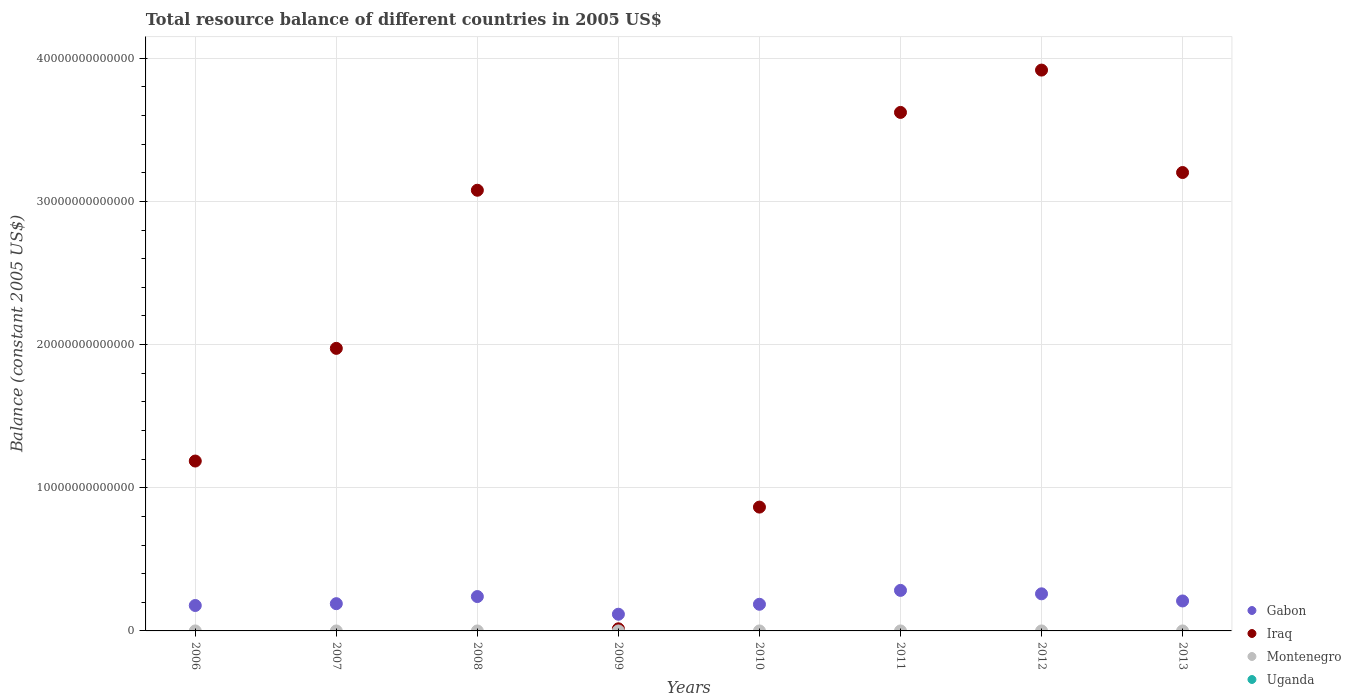How many different coloured dotlines are there?
Provide a short and direct response. 2. Is the number of dotlines equal to the number of legend labels?
Your response must be concise. No. What is the total resource balance in Iraq in 2010?
Make the answer very short. 8.65e+12. Across all years, what is the maximum total resource balance in Gabon?
Provide a short and direct response. 2.83e+12. Across all years, what is the minimum total resource balance in Gabon?
Your answer should be very brief. 1.17e+12. What is the total total resource balance in Iraq in the graph?
Provide a succinct answer. 1.79e+14. What is the difference between the total resource balance in Iraq in 2006 and that in 2010?
Keep it short and to the point. 3.22e+12. What is the difference between the total resource balance in Uganda in 2009 and the total resource balance in Montenegro in 2008?
Keep it short and to the point. 0. What is the average total resource balance in Iraq per year?
Your response must be concise. 2.23e+13. In the year 2012, what is the difference between the total resource balance in Iraq and total resource balance in Gabon?
Your answer should be compact. 3.66e+13. In how many years, is the total resource balance in Montenegro greater than 10000000000000 US$?
Your answer should be very brief. 0. What is the ratio of the total resource balance in Gabon in 2007 to that in 2009?
Make the answer very short. 1.63. Is the difference between the total resource balance in Iraq in 2007 and 2012 greater than the difference between the total resource balance in Gabon in 2007 and 2012?
Give a very brief answer. No. What is the difference between the highest and the second highest total resource balance in Iraq?
Provide a short and direct response. 2.96e+12. What is the difference between the highest and the lowest total resource balance in Iraq?
Make the answer very short. 3.90e+13. In how many years, is the total resource balance in Iraq greater than the average total resource balance in Iraq taken over all years?
Ensure brevity in your answer.  4. Is the sum of the total resource balance in Iraq in 2006 and 2010 greater than the maximum total resource balance in Uganda across all years?
Give a very brief answer. Yes. Is it the case that in every year, the sum of the total resource balance in Montenegro and total resource balance in Gabon  is greater than the total resource balance in Iraq?
Provide a succinct answer. No. Does the total resource balance in Montenegro monotonically increase over the years?
Offer a very short reply. No. Is the total resource balance in Uganda strictly greater than the total resource balance in Iraq over the years?
Give a very brief answer. No. Is the total resource balance in Montenegro strictly less than the total resource balance in Gabon over the years?
Provide a succinct answer. Yes. How many years are there in the graph?
Your answer should be compact. 8. What is the difference between two consecutive major ticks on the Y-axis?
Offer a terse response. 1.00e+13. Are the values on the major ticks of Y-axis written in scientific E-notation?
Give a very brief answer. No. Does the graph contain any zero values?
Your answer should be compact. Yes. How many legend labels are there?
Provide a short and direct response. 4. How are the legend labels stacked?
Ensure brevity in your answer.  Vertical. What is the title of the graph?
Your answer should be compact. Total resource balance of different countries in 2005 US$. Does "Brunei Darussalam" appear as one of the legend labels in the graph?
Give a very brief answer. No. What is the label or title of the X-axis?
Offer a terse response. Years. What is the label or title of the Y-axis?
Provide a succinct answer. Balance (constant 2005 US$). What is the Balance (constant 2005 US$) in Gabon in 2006?
Your response must be concise. 1.78e+12. What is the Balance (constant 2005 US$) in Iraq in 2006?
Ensure brevity in your answer.  1.19e+13. What is the Balance (constant 2005 US$) of Gabon in 2007?
Provide a short and direct response. 1.90e+12. What is the Balance (constant 2005 US$) in Iraq in 2007?
Keep it short and to the point. 1.97e+13. What is the Balance (constant 2005 US$) of Gabon in 2008?
Offer a very short reply. 2.40e+12. What is the Balance (constant 2005 US$) in Iraq in 2008?
Make the answer very short. 3.08e+13. What is the Balance (constant 2005 US$) in Uganda in 2008?
Your answer should be very brief. 0. What is the Balance (constant 2005 US$) of Gabon in 2009?
Offer a terse response. 1.17e+12. What is the Balance (constant 2005 US$) of Iraq in 2009?
Offer a terse response. 1.47e+11. What is the Balance (constant 2005 US$) of Gabon in 2010?
Your answer should be compact. 1.86e+12. What is the Balance (constant 2005 US$) in Iraq in 2010?
Ensure brevity in your answer.  8.65e+12. What is the Balance (constant 2005 US$) of Montenegro in 2010?
Provide a succinct answer. 0. What is the Balance (constant 2005 US$) of Uganda in 2010?
Your answer should be compact. 0. What is the Balance (constant 2005 US$) in Gabon in 2011?
Keep it short and to the point. 2.83e+12. What is the Balance (constant 2005 US$) of Iraq in 2011?
Your answer should be very brief. 3.62e+13. What is the Balance (constant 2005 US$) of Montenegro in 2011?
Provide a succinct answer. 0. What is the Balance (constant 2005 US$) of Uganda in 2011?
Make the answer very short. 0. What is the Balance (constant 2005 US$) in Gabon in 2012?
Provide a short and direct response. 2.59e+12. What is the Balance (constant 2005 US$) in Iraq in 2012?
Ensure brevity in your answer.  3.92e+13. What is the Balance (constant 2005 US$) in Montenegro in 2012?
Offer a very short reply. 0. What is the Balance (constant 2005 US$) in Gabon in 2013?
Provide a short and direct response. 2.09e+12. What is the Balance (constant 2005 US$) of Iraq in 2013?
Provide a succinct answer. 3.20e+13. What is the Balance (constant 2005 US$) of Montenegro in 2013?
Your response must be concise. 0. Across all years, what is the maximum Balance (constant 2005 US$) in Gabon?
Your answer should be very brief. 2.83e+12. Across all years, what is the maximum Balance (constant 2005 US$) of Iraq?
Give a very brief answer. 3.92e+13. Across all years, what is the minimum Balance (constant 2005 US$) of Gabon?
Provide a succinct answer. 1.17e+12. Across all years, what is the minimum Balance (constant 2005 US$) in Iraq?
Your response must be concise. 1.47e+11. What is the total Balance (constant 2005 US$) in Gabon in the graph?
Your answer should be compact. 1.66e+13. What is the total Balance (constant 2005 US$) of Iraq in the graph?
Your answer should be compact. 1.79e+14. What is the total Balance (constant 2005 US$) in Montenegro in the graph?
Your answer should be compact. 0. What is the difference between the Balance (constant 2005 US$) in Gabon in 2006 and that in 2007?
Offer a terse response. -1.28e+11. What is the difference between the Balance (constant 2005 US$) in Iraq in 2006 and that in 2007?
Give a very brief answer. -7.87e+12. What is the difference between the Balance (constant 2005 US$) in Gabon in 2006 and that in 2008?
Provide a short and direct response. -6.25e+11. What is the difference between the Balance (constant 2005 US$) of Iraq in 2006 and that in 2008?
Keep it short and to the point. -1.89e+13. What is the difference between the Balance (constant 2005 US$) of Gabon in 2006 and that in 2009?
Give a very brief answer. 6.09e+11. What is the difference between the Balance (constant 2005 US$) in Iraq in 2006 and that in 2009?
Provide a succinct answer. 1.17e+13. What is the difference between the Balance (constant 2005 US$) in Gabon in 2006 and that in 2010?
Give a very brief answer. -8.58e+1. What is the difference between the Balance (constant 2005 US$) of Iraq in 2006 and that in 2010?
Give a very brief answer. 3.22e+12. What is the difference between the Balance (constant 2005 US$) of Gabon in 2006 and that in 2011?
Give a very brief answer. -1.06e+12. What is the difference between the Balance (constant 2005 US$) of Iraq in 2006 and that in 2011?
Offer a very short reply. -2.43e+13. What is the difference between the Balance (constant 2005 US$) in Gabon in 2006 and that in 2012?
Provide a succinct answer. -8.16e+11. What is the difference between the Balance (constant 2005 US$) in Iraq in 2006 and that in 2012?
Provide a succinct answer. -2.73e+13. What is the difference between the Balance (constant 2005 US$) in Gabon in 2006 and that in 2013?
Your answer should be very brief. -3.17e+11. What is the difference between the Balance (constant 2005 US$) in Iraq in 2006 and that in 2013?
Give a very brief answer. -2.02e+13. What is the difference between the Balance (constant 2005 US$) in Gabon in 2007 and that in 2008?
Ensure brevity in your answer.  -4.98e+11. What is the difference between the Balance (constant 2005 US$) in Iraq in 2007 and that in 2008?
Ensure brevity in your answer.  -1.10e+13. What is the difference between the Balance (constant 2005 US$) of Gabon in 2007 and that in 2009?
Make the answer very short. 7.37e+11. What is the difference between the Balance (constant 2005 US$) in Iraq in 2007 and that in 2009?
Your answer should be very brief. 1.96e+13. What is the difference between the Balance (constant 2005 US$) of Gabon in 2007 and that in 2010?
Ensure brevity in your answer.  4.21e+1. What is the difference between the Balance (constant 2005 US$) in Iraq in 2007 and that in 2010?
Offer a very short reply. 1.11e+13. What is the difference between the Balance (constant 2005 US$) of Gabon in 2007 and that in 2011?
Ensure brevity in your answer.  -9.28e+11. What is the difference between the Balance (constant 2005 US$) in Iraq in 2007 and that in 2011?
Provide a succinct answer. -1.65e+13. What is the difference between the Balance (constant 2005 US$) in Gabon in 2007 and that in 2012?
Keep it short and to the point. -6.88e+11. What is the difference between the Balance (constant 2005 US$) in Iraq in 2007 and that in 2012?
Provide a succinct answer. -1.94e+13. What is the difference between the Balance (constant 2005 US$) in Gabon in 2007 and that in 2013?
Offer a very short reply. -1.90e+11. What is the difference between the Balance (constant 2005 US$) in Iraq in 2007 and that in 2013?
Your answer should be compact. -1.23e+13. What is the difference between the Balance (constant 2005 US$) of Gabon in 2008 and that in 2009?
Your response must be concise. 1.23e+12. What is the difference between the Balance (constant 2005 US$) of Iraq in 2008 and that in 2009?
Your response must be concise. 3.06e+13. What is the difference between the Balance (constant 2005 US$) in Gabon in 2008 and that in 2010?
Offer a terse response. 5.40e+11. What is the difference between the Balance (constant 2005 US$) of Iraq in 2008 and that in 2010?
Your answer should be compact. 2.21e+13. What is the difference between the Balance (constant 2005 US$) of Gabon in 2008 and that in 2011?
Give a very brief answer. -4.30e+11. What is the difference between the Balance (constant 2005 US$) of Iraq in 2008 and that in 2011?
Provide a succinct answer. -5.44e+12. What is the difference between the Balance (constant 2005 US$) in Gabon in 2008 and that in 2012?
Your answer should be compact. -1.91e+11. What is the difference between the Balance (constant 2005 US$) of Iraq in 2008 and that in 2012?
Your answer should be compact. -8.39e+12. What is the difference between the Balance (constant 2005 US$) in Gabon in 2008 and that in 2013?
Make the answer very short. 3.08e+11. What is the difference between the Balance (constant 2005 US$) in Iraq in 2008 and that in 2013?
Your answer should be compact. -1.24e+12. What is the difference between the Balance (constant 2005 US$) of Gabon in 2009 and that in 2010?
Keep it short and to the point. -6.95e+11. What is the difference between the Balance (constant 2005 US$) in Iraq in 2009 and that in 2010?
Make the answer very short. -8.50e+12. What is the difference between the Balance (constant 2005 US$) in Gabon in 2009 and that in 2011?
Make the answer very short. -1.66e+12. What is the difference between the Balance (constant 2005 US$) in Iraq in 2009 and that in 2011?
Offer a terse response. -3.61e+13. What is the difference between the Balance (constant 2005 US$) in Gabon in 2009 and that in 2012?
Provide a succinct answer. -1.42e+12. What is the difference between the Balance (constant 2005 US$) of Iraq in 2009 and that in 2012?
Offer a terse response. -3.90e+13. What is the difference between the Balance (constant 2005 US$) in Gabon in 2009 and that in 2013?
Offer a terse response. -9.26e+11. What is the difference between the Balance (constant 2005 US$) in Iraq in 2009 and that in 2013?
Make the answer very short. -3.19e+13. What is the difference between the Balance (constant 2005 US$) of Gabon in 2010 and that in 2011?
Give a very brief answer. -9.70e+11. What is the difference between the Balance (constant 2005 US$) in Iraq in 2010 and that in 2011?
Make the answer very short. -2.76e+13. What is the difference between the Balance (constant 2005 US$) in Gabon in 2010 and that in 2012?
Give a very brief answer. -7.30e+11. What is the difference between the Balance (constant 2005 US$) of Iraq in 2010 and that in 2012?
Provide a short and direct response. -3.05e+13. What is the difference between the Balance (constant 2005 US$) of Gabon in 2010 and that in 2013?
Offer a very short reply. -2.32e+11. What is the difference between the Balance (constant 2005 US$) of Iraq in 2010 and that in 2013?
Your answer should be very brief. -2.34e+13. What is the difference between the Balance (constant 2005 US$) of Gabon in 2011 and that in 2012?
Your answer should be compact. 2.40e+11. What is the difference between the Balance (constant 2005 US$) in Iraq in 2011 and that in 2012?
Give a very brief answer. -2.96e+12. What is the difference between the Balance (constant 2005 US$) of Gabon in 2011 and that in 2013?
Make the answer very short. 7.38e+11. What is the difference between the Balance (constant 2005 US$) in Iraq in 2011 and that in 2013?
Make the answer very short. 4.20e+12. What is the difference between the Balance (constant 2005 US$) in Gabon in 2012 and that in 2013?
Ensure brevity in your answer.  4.99e+11. What is the difference between the Balance (constant 2005 US$) of Iraq in 2012 and that in 2013?
Your answer should be very brief. 7.15e+12. What is the difference between the Balance (constant 2005 US$) of Gabon in 2006 and the Balance (constant 2005 US$) of Iraq in 2007?
Provide a short and direct response. -1.80e+13. What is the difference between the Balance (constant 2005 US$) of Gabon in 2006 and the Balance (constant 2005 US$) of Iraq in 2008?
Provide a short and direct response. -2.90e+13. What is the difference between the Balance (constant 2005 US$) of Gabon in 2006 and the Balance (constant 2005 US$) of Iraq in 2009?
Your answer should be very brief. 1.63e+12. What is the difference between the Balance (constant 2005 US$) in Gabon in 2006 and the Balance (constant 2005 US$) in Iraq in 2010?
Provide a short and direct response. -6.87e+12. What is the difference between the Balance (constant 2005 US$) in Gabon in 2006 and the Balance (constant 2005 US$) in Iraq in 2011?
Provide a short and direct response. -3.44e+13. What is the difference between the Balance (constant 2005 US$) of Gabon in 2006 and the Balance (constant 2005 US$) of Iraq in 2012?
Offer a very short reply. -3.74e+13. What is the difference between the Balance (constant 2005 US$) of Gabon in 2006 and the Balance (constant 2005 US$) of Iraq in 2013?
Provide a succinct answer. -3.02e+13. What is the difference between the Balance (constant 2005 US$) of Gabon in 2007 and the Balance (constant 2005 US$) of Iraq in 2008?
Your answer should be very brief. -2.89e+13. What is the difference between the Balance (constant 2005 US$) of Gabon in 2007 and the Balance (constant 2005 US$) of Iraq in 2009?
Keep it short and to the point. 1.76e+12. What is the difference between the Balance (constant 2005 US$) in Gabon in 2007 and the Balance (constant 2005 US$) in Iraq in 2010?
Provide a succinct answer. -6.74e+12. What is the difference between the Balance (constant 2005 US$) of Gabon in 2007 and the Balance (constant 2005 US$) of Iraq in 2011?
Offer a terse response. -3.43e+13. What is the difference between the Balance (constant 2005 US$) in Gabon in 2007 and the Balance (constant 2005 US$) in Iraq in 2012?
Provide a short and direct response. -3.73e+13. What is the difference between the Balance (constant 2005 US$) of Gabon in 2007 and the Balance (constant 2005 US$) of Iraq in 2013?
Give a very brief answer. -3.01e+13. What is the difference between the Balance (constant 2005 US$) of Gabon in 2008 and the Balance (constant 2005 US$) of Iraq in 2009?
Give a very brief answer. 2.25e+12. What is the difference between the Balance (constant 2005 US$) of Gabon in 2008 and the Balance (constant 2005 US$) of Iraq in 2010?
Offer a terse response. -6.25e+12. What is the difference between the Balance (constant 2005 US$) of Gabon in 2008 and the Balance (constant 2005 US$) of Iraq in 2011?
Keep it short and to the point. -3.38e+13. What is the difference between the Balance (constant 2005 US$) of Gabon in 2008 and the Balance (constant 2005 US$) of Iraq in 2012?
Provide a succinct answer. -3.68e+13. What is the difference between the Balance (constant 2005 US$) in Gabon in 2008 and the Balance (constant 2005 US$) in Iraq in 2013?
Your answer should be very brief. -2.96e+13. What is the difference between the Balance (constant 2005 US$) of Gabon in 2009 and the Balance (constant 2005 US$) of Iraq in 2010?
Your response must be concise. -7.48e+12. What is the difference between the Balance (constant 2005 US$) of Gabon in 2009 and the Balance (constant 2005 US$) of Iraq in 2011?
Your answer should be very brief. -3.50e+13. What is the difference between the Balance (constant 2005 US$) in Gabon in 2009 and the Balance (constant 2005 US$) in Iraq in 2012?
Your answer should be compact. -3.80e+13. What is the difference between the Balance (constant 2005 US$) of Gabon in 2009 and the Balance (constant 2005 US$) of Iraq in 2013?
Give a very brief answer. -3.09e+13. What is the difference between the Balance (constant 2005 US$) of Gabon in 2010 and the Balance (constant 2005 US$) of Iraq in 2011?
Offer a terse response. -3.44e+13. What is the difference between the Balance (constant 2005 US$) in Gabon in 2010 and the Balance (constant 2005 US$) in Iraq in 2012?
Your answer should be compact. -3.73e+13. What is the difference between the Balance (constant 2005 US$) in Gabon in 2010 and the Balance (constant 2005 US$) in Iraq in 2013?
Your answer should be very brief. -3.02e+13. What is the difference between the Balance (constant 2005 US$) in Gabon in 2011 and the Balance (constant 2005 US$) in Iraq in 2012?
Provide a short and direct response. -3.63e+13. What is the difference between the Balance (constant 2005 US$) in Gabon in 2011 and the Balance (constant 2005 US$) in Iraq in 2013?
Give a very brief answer. -2.92e+13. What is the difference between the Balance (constant 2005 US$) in Gabon in 2012 and the Balance (constant 2005 US$) in Iraq in 2013?
Provide a short and direct response. -2.94e+13. What is the average Balance (constant 2005 US$) in Gabon per year?
Offer a terse response. 2.08e+12. What is the average Balance (constant 2005 US$) in Iraq per year?
Give a very brief answer. 2.23e+13. What is the average Balance (constant 2005 US$) of Montenegro per year?
Give a very brief answer. 0. In the year 2006, what is the difference between the Balance (constant 2005 US$) in Gabon and Balance (constant 2005 US$) in Iraq?
Keep it short and to the point. -1.01e+13. In the year 2007, what is the difference between the Balance (constant 2005 US$) of Gabon and Balance (constant 2005 US$) of Iraq?
Give a very brief answer. -1.78e+13. In the year 2008, what is the difference between the Balance (constant 2005 US$) of Gabon and Balance (constant 2005 US$) of Iraq?
Keep it short and to the point. -2.84e+13. In the year 2009, what is the difference between the Balance (constant 2005 US$) in Gabon and Balance (constant 2005 US$) in Iraq?
Provide a short and direct response. 1.02e+12. In the year 2010, what is the difference between the Balance (constant 2005 US$) of Gabon and Balance (constant 2005 US$) of Iraq?
Offer a very short reply. -6.79e+12. In the year 2011, what is the difference between the Balance (constant 2005 US$) in Gabon and Balance (constant 2005 US$) in Iraq?
Provide a short and direct response. -3.34e+13. In the year 2012, what is the difference between the Balance (constant 2005 US$) in Gabon and Balance (constant 2005 US$) in Iraq?
Provide a succinct answer. -3.66e+13. In the year 2013, what is the difference between the Balance (constant 2005 US$) in Gabon and Balance (constant 2005 US$) in Iraq?
Provide a short and direct response. -2.99e+13. What is the ratio of the Balance (constant 2005 US$) of Gabon in 2006 to that in 2007?
Offer a very short reply. 0.93. What is the ratio of the Balance (constant 2005 US$) of Iraq in 2006 to that in 2007?
Give a very brief answer. 0.6. What is the ratio of the Balance (constant 2005 US$) in Gabon in 2006 to that in 2008?
Offer a terse response. 0.74. What is the ratio of the Balance (constant 2005 US$) of Iraq in 2006 to that in 2008?
Your response must be concise. 0.39. What is the ratio of the Balance (constant 2005 US$) in Gabon in 2006 to that in 2009?
Offer a terse response. 1.52. What is the ratio of the Balance (constant 2005 US$) in Iraq in 2006 to that in 2009?
Keep it short and to the point. 80.49. What is the ratio of the Balance (constant 2005 US$) of Gabon in 2006 to that in 2010?
Ensure brevity in your answer.  0.95. What is the ratio of the Balance (constant 2005 US$) of Iraq in 2006 to that in 2010?
Offer a very short reply. 1.37. What is the ratio of the Balance (constant 2005 US$) in Gabon in 2006 to that in 2011?
Ensure brevity in your answer.  0.63. What is the ratio of the Balance (constant 2005 US$) of Iraq in 2006 to that in 2011?
Provide a succinct answer. 0.33. What is the ratio of the Balance (constant 2005 US$) of Gabon in 2006 to that in 2012?
Provide a short and direct response. 0.69. What is the ratio of the Balance (constant 2005 US$) of Iraq in 2006 to that in 2012?
Offer a very short reply. 0.3. What is the ratio of the Balance (constant 2005 US$) in Gabon in 2006 to that in 2013?
Your answer should be very brief. 0.85. What is the ratio of the Balance (constant 2005 US$) of Iraq in 2006 to that in 2013?
Provide a short and direct response. 0.37. What is the ratio of the Balance (constant 2005 US$) of Gabon in 2007 to that in 2008?
Offer a terse response. 0.79. What is the ratio of the Balance (constant 2005 US$) of Iraq in 2007 to that in 2008?
Provide a succinct answer. 0.64. What is the ratio of the Balance (constant 2005 US$) in Gabon in 2007 to that in 2009?
Your response must be concise. 1.63. What is the ratio of the Balance (constant 2005 US$) of Iraq in 2007 to that in 2009?
Make the answer very short. 133.87. What is the ratio of the Balance (constant 2005 US$) in Gabon in 2007 to that in 2010?
Offer a very short reply. 1.02. What is the ratio of the Balance (constant 2005 US$) in Iraq in 2007 to that in 2010?
Your answer should be very brief. 2.28. What is the ratio of the Balance (constant 2005 US$) in Gabon in 2007 to that in 2011?
Ensure brevity in your answer.  0.67. What is the ratio of the Balance (constant 2005 US$) of Iraq in 2007 to that in 2011?
Your answer should be very brief. 0.55. What is the ratio of the Balance (constant 2005 US$) of Gabon in 2007 to that in 2012?
Offer a terse response. 0.73. What is the ratio of the Balance (constant 2005 US$) of Iraq in 2007 to that in 2012?
Your answer should be compact. 0.5. What is the ratio of the Balance (constant 2005 US$) of Gabon in 2007 to that in 2013?
Make the answer very short. 0.91. What is the ratio of the Balance (constant 2005 US$) in Iraq in 2007 to that in 2013?
Give a very brief answer. 0.62. What is the ratio of the Balance (constant 2005 US$) in Gabon in 2008 to that in 2009?
Make the answer very short. 2.06. What is the ratio of the Balance (constant 2005 US$) in Iraq in 2008 to that in 2009?
Provide a short and direct response. 208.78. What is the ratio of the Balance (constant 2005 US$) in Gabon in 2008 to that in 2010?
Your answer should be very brief. 1.29. What is the ratio of the Balance (constant 2005 US$) of Iraq in 2008 to that in 2010?
Offer a very short reply. 3.56. What is the ratio of the Balance (constant 2005 US$) of Gabon in 2008 to that in 2011?
Provide a short and direct response. 0.85. What is the ratio of the Balance (constant 2005 US$) in Iraq in 2008 to that in 2011?
Offer a terse response. 0.85. What is the ratio of the Balance (constant 2005 US$) in Gabon in 2008 to that in 2012?
Offer a terse response. 0.93. What is the ratio of the Balance (constant 2005 US$) of Iraq in 2008 to that in 2012?
Provide a succinct answer. 0.79. What is the ratio of the Balance (constant 2005 US$) in Gabon in 2008 to that in 2013?
Offer a terse response. 1.15. What is the ratio of the Balance (constant 2005 US$) of Iraq in 2008 to that in 2013?
Provide a short and direct response. 0.96. What is the ratio of the Balance (constant 2005 US$) in Gabon in 2009 to that in 2010?
Your answer should be very brief. 0.63. What is the ratio of the Balance (constant 2005 US$) in Iraq in 2009 to that in 2010?
Your answer should be very brief. 0.02. What is the ratio of the Balance (constant 2005 US$) of Gabon in 2009 to that in 2011?
Your answer should be compact. 0.41. What is the ratio of the Balance (constant 2005 US$) in Iraq in 2009 to that in 2011?
Keep it short and to the point. 0. What is the ratio of the Balance (constant 2005 US$) of Gabon in 2009 to that in 2012?
Offer a very short reply. 0.45. What is the ratio of the Balance (constant 2005 US$) of Iraq in 2009 to that in 2012?
Your answer should be very brief. 0. What is the ratio of the Balance (constant 2005 US$) of Gabon in 2009 to that in 2013?
Make the answer very short. 0.56. What is the ratio of the Balance (constant 2005 US$) in Iraq in 2009 to that in 2013?
Make the answer very short. 0. What is the ratio of the Balance (constant 2005 US$) of Gabon in 2010 to that in 2011?
Provide a succinct answer. 0.66. What is the ratio of the Balance (constant 2005 US$) of Iraq in 2010 to that in 2011?
Your response must be concise. 0.24. What is the ratio of the Balance (constant 2005 US$) of Gabon in 2010 to that in 2012?
Your answer should be very brief. 0.72. What is the ratio of the Balance (constant 2005 US$) of Iraq in 2010 to that in 2012?
Keep it short and to the point. 0.22. What is the ratio of the Balance (constant 2005 US$) in Gabon in 2010 to that in 2013?
Your answer should be very brief. 0.89. What is the ratio of the Balance (constant 2005 US$) in Iraq in 2010 to that in 2013?
Offer a terse response. 0.27. What is the ratio of the Balance (constant 2005 US$) of Gabon in 2011 to that in 2012?
Offer a very short reply. 1.09. What is the ratio of the Balance (constant 2005 US$) of Iraq in 2011 to that in 2012?
Your response must be concise. 0.92. What is the ratio of the Balance (constant 2005 US$) of Gabon in 2011 to that in 2013?
Ensure brevity in your answer.  1.35. What is the ratio of the Balance (constant 2005 US$) in Iraq in 2011 to that in 2013?
Ensure brevity in your answer.  1.13. What is the ratio of the Balance (constant 2005 US$) of Gabon in 2012 to that in 2013?
Provide a short and direct response. 1.24. What is the ratio of the Balance (constant 2005 US$) in Iraq in 2012 to that in 2013?
Your answer should be very brief. 1.22. What is the difference between the highest and the second highest Balance (constant 2005 US$) in Gabon?
Provide a short and direct response. 2.40e+11. What is the difference between the highest and the second highest Balance (constant 2005 US$) in Iraq?
Ensure brevity in your answer.  2.96e+12. What is the difference between the highest and the lowest Balance (constant 2005 US$) in Gabon?
Provide a short and direct response. 1.66e+12. What is the difference between the highest and the lowest Balance (constant 2005 US$) of Iraq?
Keep it short and to the point. 3.90e+13. 